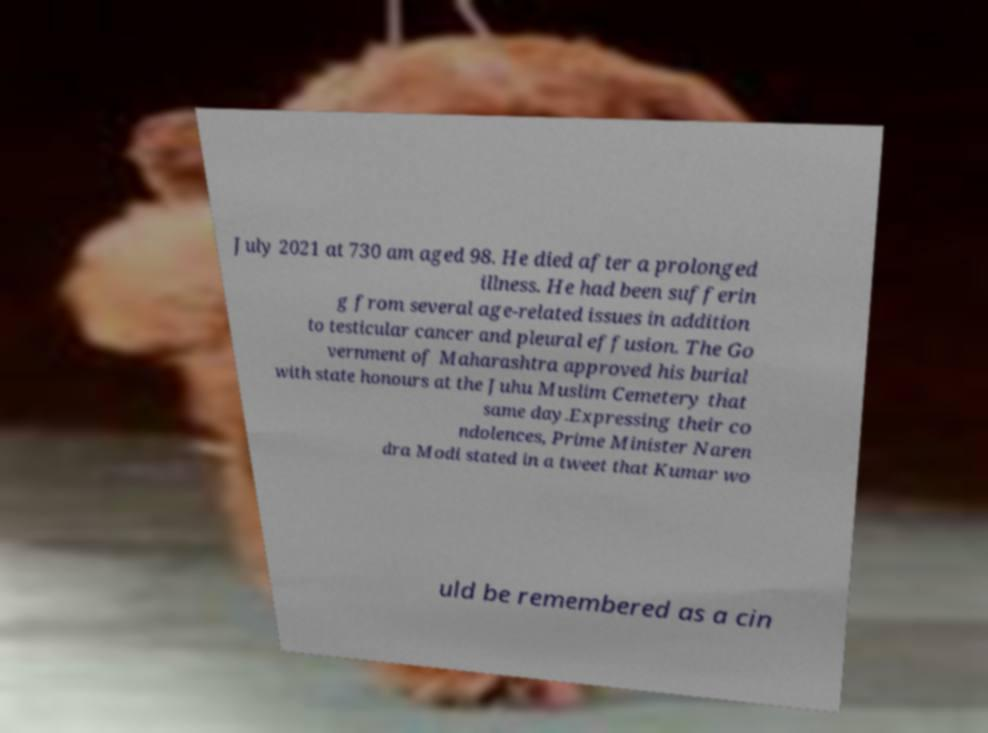Please read and relay the text visible in this image. What does it say? July 2021 at 730 am aged 98. He died after a prolonged illness. He had been sufferin g from several age-related issues in addition to testicular cancer and pleural effusion. The Go vernment of Maharashtra approved his burial with state honours at the Juhu Muslim Cemetery that same day.Expressing their co ndolences, Prime Minister Naren dra Modi stated in a tweet that Kumar wo uld be remembered as a cin 